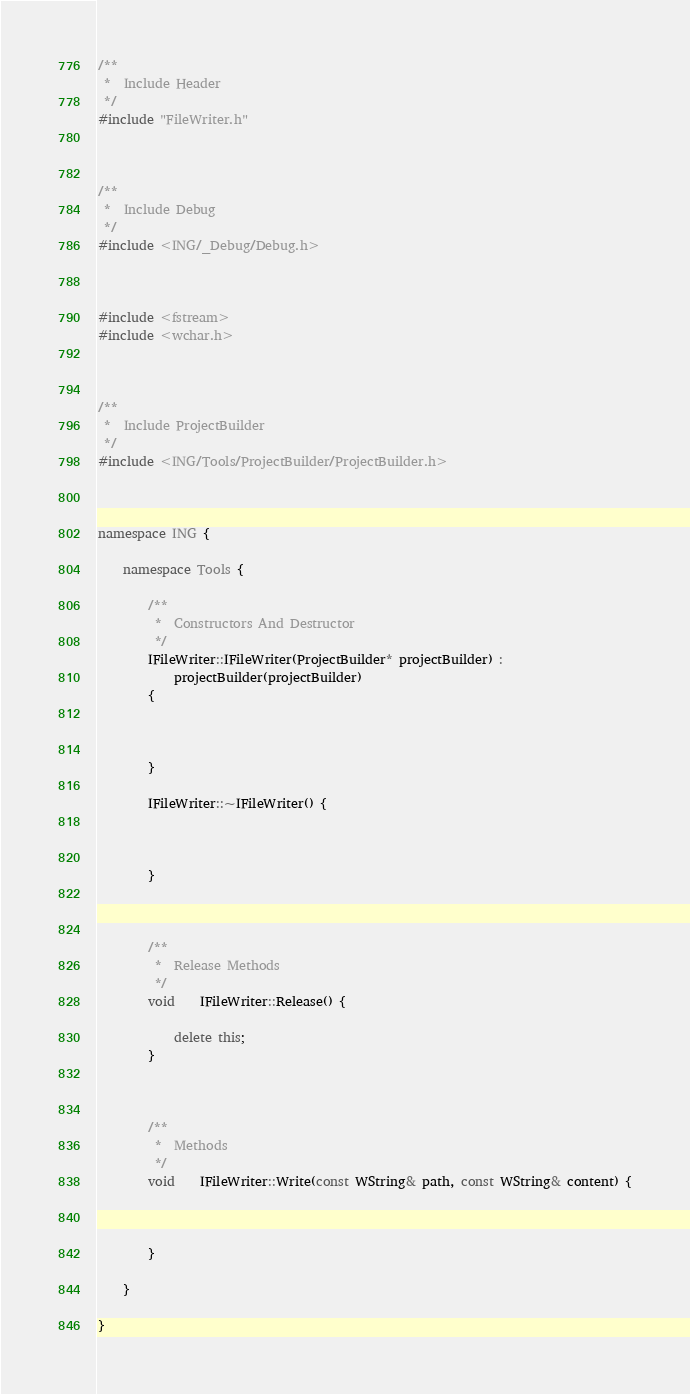Convert code to text. <code><loc_0><loc_0><loc_500><loc_500><_C++_>
/**
 *	Include Header
 */
#include "FileWriter.h"



/**
 *	Include Debug
 */
#include <ING/_Debug/Debug.h>



#include <fstream>
#include <wchar.h>



/**
 *	Include ProjectBuilder
 */
#include <ING/Tools/ProjectBuilder/ProjectBuilder.h>



namespace ING {

	namespace Tools {

		/**
		 *	Constructors And Destructor
		 */
		IFileWriter::IFileWriter(ProjectBuilder* projectBuilder) :
			projectBuilder(projectBuilder)
		{



		}

		IFileWriter::~IFileWriter() {



		}



		/**
		 *	Release Methods
		 */
		void	IFileWriter::Release() {

			delete this;
		}



		/**
		 *	Methods
		 */
		void	IFileWriter::Write(const WString& path, const WString& content) {



		}
		
	}

}</code> 